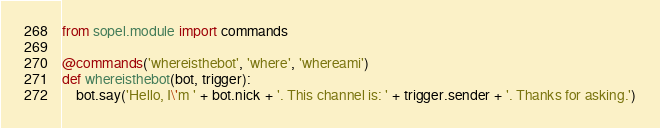<code> <loc_0><loc_0><loc_500><loc_500><_Python_>from sopel.module import commands

@commands('whereisthebot', 'where', 'whereami')
def whereisthebot(bot, trigger):
    bot.say('Hello, I\'m ' + bot.nick + '. This channel is: ' + trigger.sender + '. Thanks for asking.')
</code> 